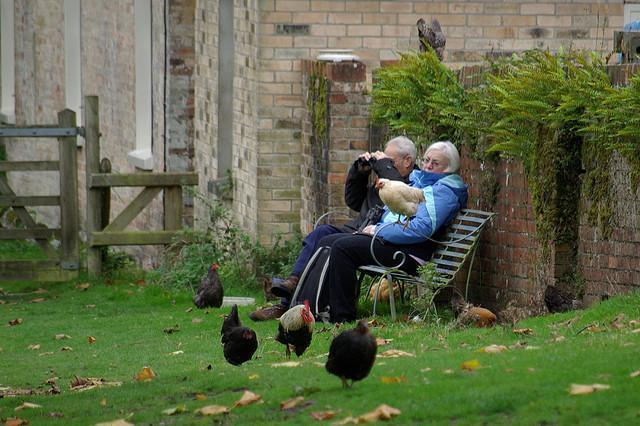What is the freshest food available to this woman?
From the following four choices, select the correct answer to address the question.
Options: Flour, chips, eggs, ice cream. Eggs. 